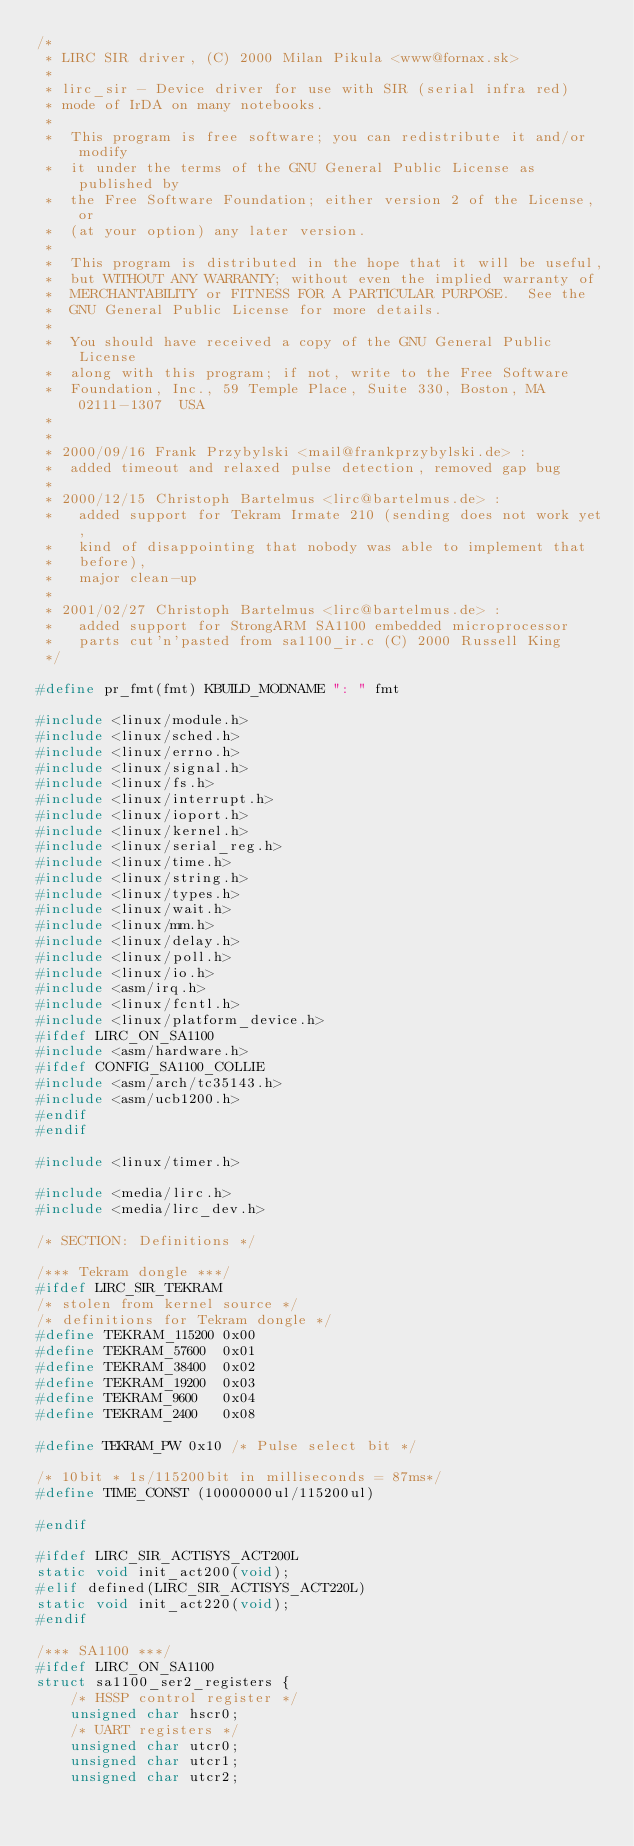Convert code to text. <code><loc_0><loc_0><loc_500><loc_500><_C_>/*
 * LIRC SIR driver, (C) 2000 Milan Pikula <www@fornax.sk>
 *
 * lirc_sir - Device driver for use with SIR (serial infra red)
 * mode of IrDA on many notebooks.
 *
 *  This program is free software; you can redistribute it and/or modify
 *  it under the terms of the GNU General Public License as published by
 *  the Free Software Foundation; either version 2 of the License, or
 *  (at your option) any later version.
 *
 *  This program is distributed in the hope that it will be useful,
 *  but WITHOUT ANY WARRANTY; without even the implied warranty of
 *  MERCHANTABILITY or FITNESS FOR A PARTICULAR PURPOSE.  See the
 *  GNU General Public License for more details.
 *
 *  You should have received a copy of the GNU General Public License
 *  along with this program; if not, write to the Free Software
 *  Foundation, Inc., 59 Temple Place, Suite 330, Boston, MA  02111-1307  USA
 *
 *
 * 2000/09/16 Frank Przybylski <mail@frankprzybylski.de> :
 *  added timeout and relaxed pulse detection, removed gap bug
 *
 * 2000/12/15 Christoph Bartelmus <lirc@bartelmus.de> :
 *   added support for Tekram Irmate 210 (sending does not work yet,
 *   kind of disappointing that nobody was able to implement that
 *   before),
 *   major clean-up
 *
 * 2001/02/27 Christoph Bartelmus <lirc@bartelmus.de> :
 *   added support for StrongARM SA1100 embedded microprocessor
 *   parts cut'n'pasted from sa1100_ir.c (C) 2000 Russell King
 */

#define pr_fmt(fmt) KBUILD_MODNAME ": " fmt

#include <linux/module.h>
#include <linux/sched.h>
#include <linux/errno.h>
#include <linux/signal.h>
#include <linux/fs.h>
#include <linux/interrupt.h>
#include <linux/ioport.h>
#include <linux/kernel.h>
#include <linux/serial_reg.h>
#include <linux/time.h>
#include <linux/string.h>
#include <linux/types.h>
#include <linux/wait.h>
#include <linux/mm.h>
#include <linux/delay.h>
#include <linux/poll.h>
#include <linux/io.h>
#include <asm/irq.h>
#include <linux/fcntl.h>
#include <linux/platform_device.h>
#ifdef LIRC_ON_SA1100
#include <asm/hardware.h>
#ifdef CONFIG_SA1100_COLLIE
#include <asm/arch/tc35143.h>
#include <asm/ucb1200.h>
#endif
#endif

#include <linux/timer.h>

#include <media/lirc.h>
#include <media/lirc_dev.h>

/* SECTION: Definitions */

/*** Tekram dongle ***/
#ifdef LIRC_SIR_TEKRAM
/* stolen from kernel source */
/* definitions for Tekram dongle */
#define TEKRAM_115200 0x00
#define TEKRAM_57600  0x01
#define TEKRAM_38400  0x02
#define TEKRAM_19200  0x03
#define TEKRAM_9600   0x04
#define TEKRAM_2400   0x08

#define TEKRAM_PW 0x10 /* Pulse select bit */

/* 10bit * 1s/115200bit in milliseconds = 87ms*/
#define TIME_CONST (10000000ul/115200ul)

#endif

#ifdef LIRC_SIR_ACTISYS_ACT200L
static void init_act200(void);
#elif defined(LIRC_SIR_ACTISYS_ACT220L)
static void init_act220(void);
#endif

/*** SA1100 ***/
#ifdef LIRC_ON_SA1100
struct sa1100_ser2_registers {
	/* HSSP control register */
	unsigned char hscr0;
	/* UART registers */
	unsigned char utcr0;
	unsigned char utcr1;
	unsigned char utcr2;</code> 